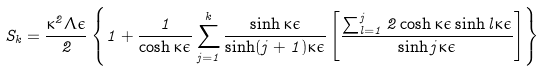<formula> <loc_0><loc_0><loc_500><loc_500>S _ { k } = \frac { \kappa ^ { 2 } \Lambda \epsilon } { 2 } \left \{ 1 + \frac { 1 } { \cosh \kappa \epsilon } \sum _ { j = 1 } ^ { k } \frac { \sinh \kappa \epsilon } { \sinh ( j + 1 ) \kappa \epsilon } \left [ \frac { \sum _ { l = 1 } ^ { j } 2 \cosh \kappa \epsilon \sinh l \kappa \epsilon } { \sinh j \kappa \epsilon } \right ] \right \}</formula> 